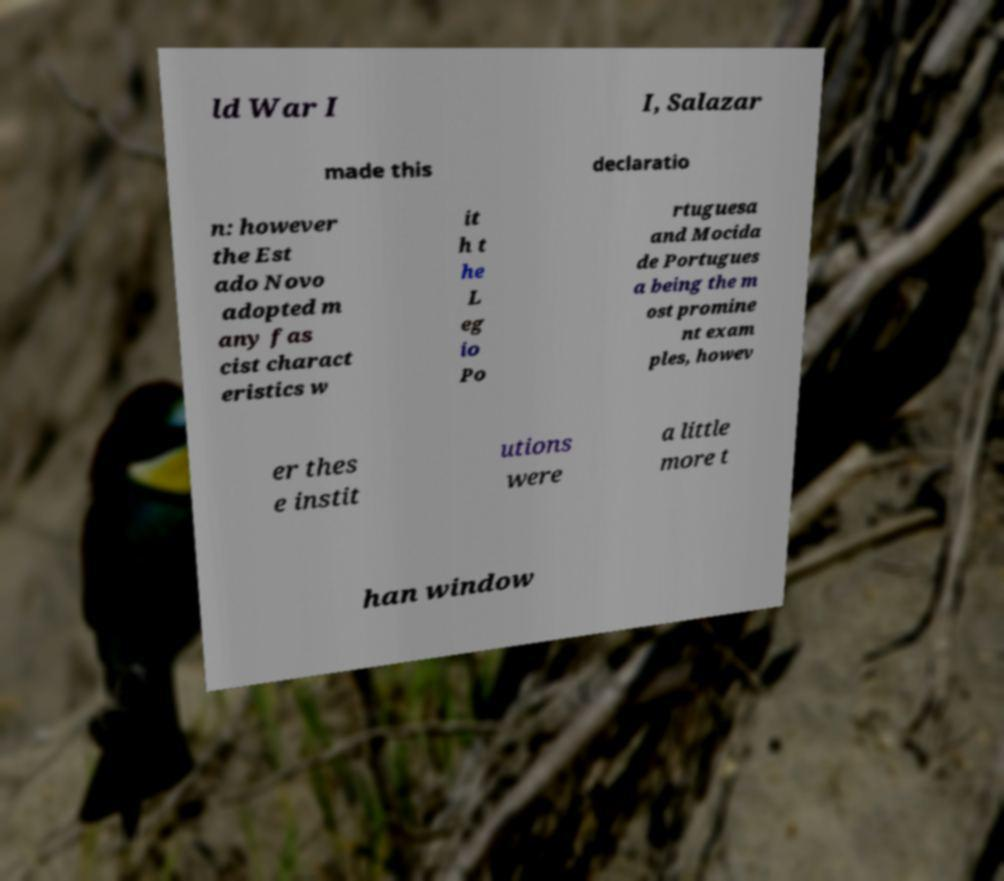Can you accurately transcribe the text from the provided image for me? ld War I I, Salazar made this declaratio n: however the Est ado Novo adopted m any fas cist charact eristics w it h t he L eg io Po rtuguesa and Mocida de Portugues a being the m ost promine nt exam ples, howev er thes e instit utions were a little more t han window 